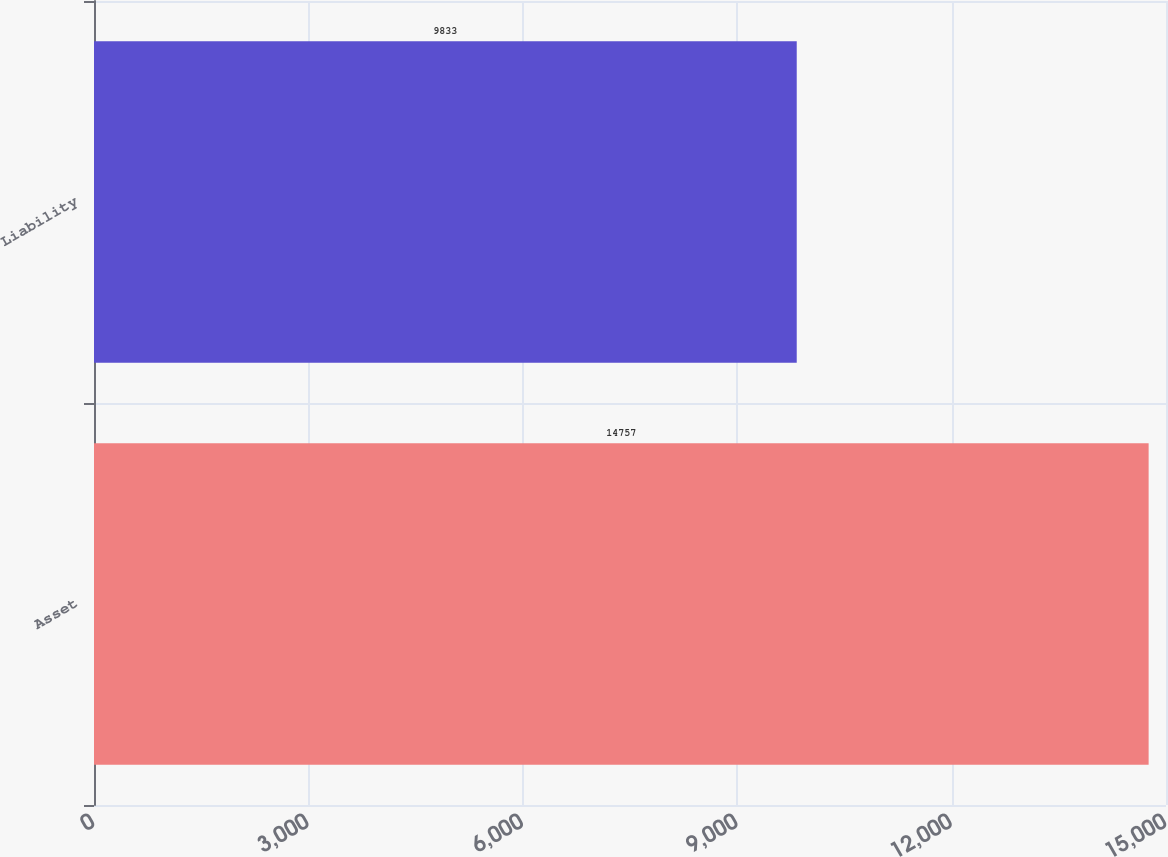Convert chart. <chart><loc_0><loc_0><loc_500><loc_500><bar_chart><fcel>Asset<fcel>Liability<nl><fcel>14757<fcel>9833<nl></chart> 